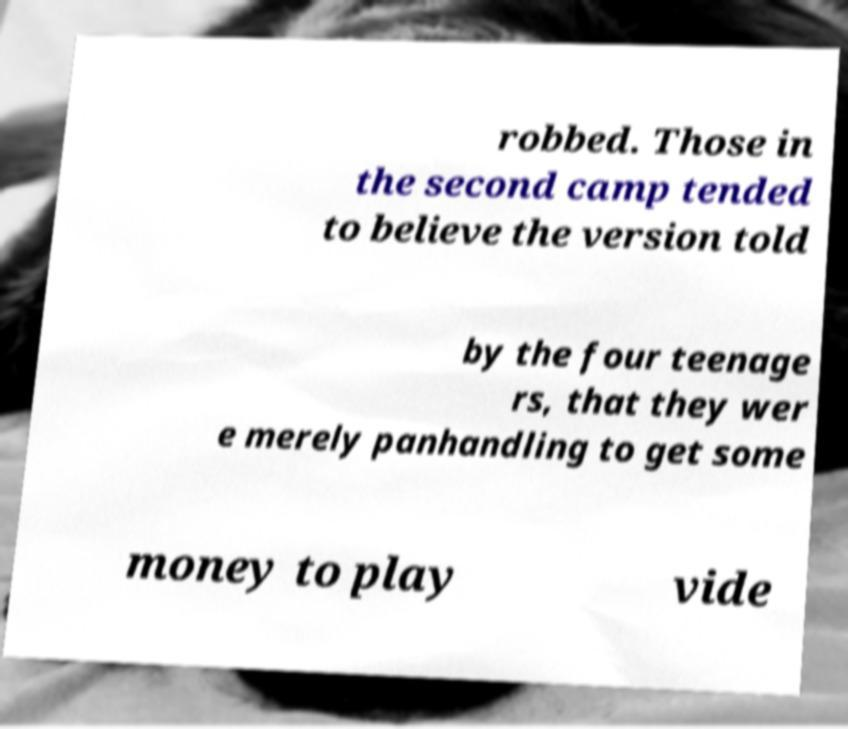Could you extract and type out the text from this image? robbed. Those in the second camp tended to believe the version told by the four teenage rs, that they wer e merely panhandling to get some money to play vide 